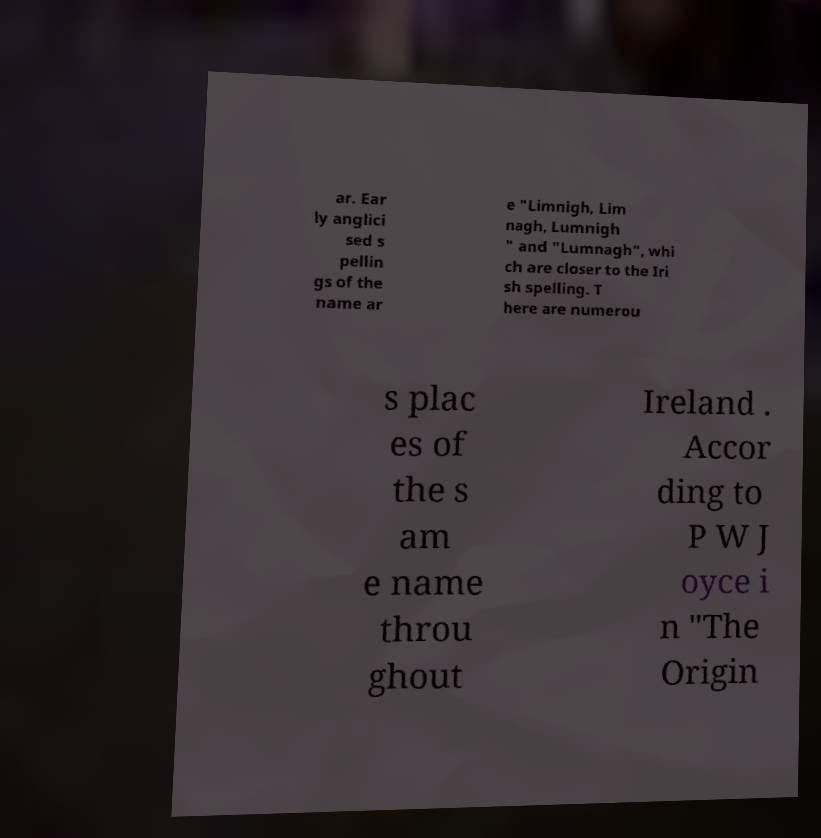Can you accurately transcribe the text from the provided image for me? ar. Ear ly anglici sed s pellin gs of the name ar e "Limnigh, Lim nagh, Lumnigh " and "Lumnagh", whi ch are closer to the Iri sh spelling. T here are numerou s plac es of the s am e name throu ghout Ireland . Accor ding to P W J oyce i n "The Origin 